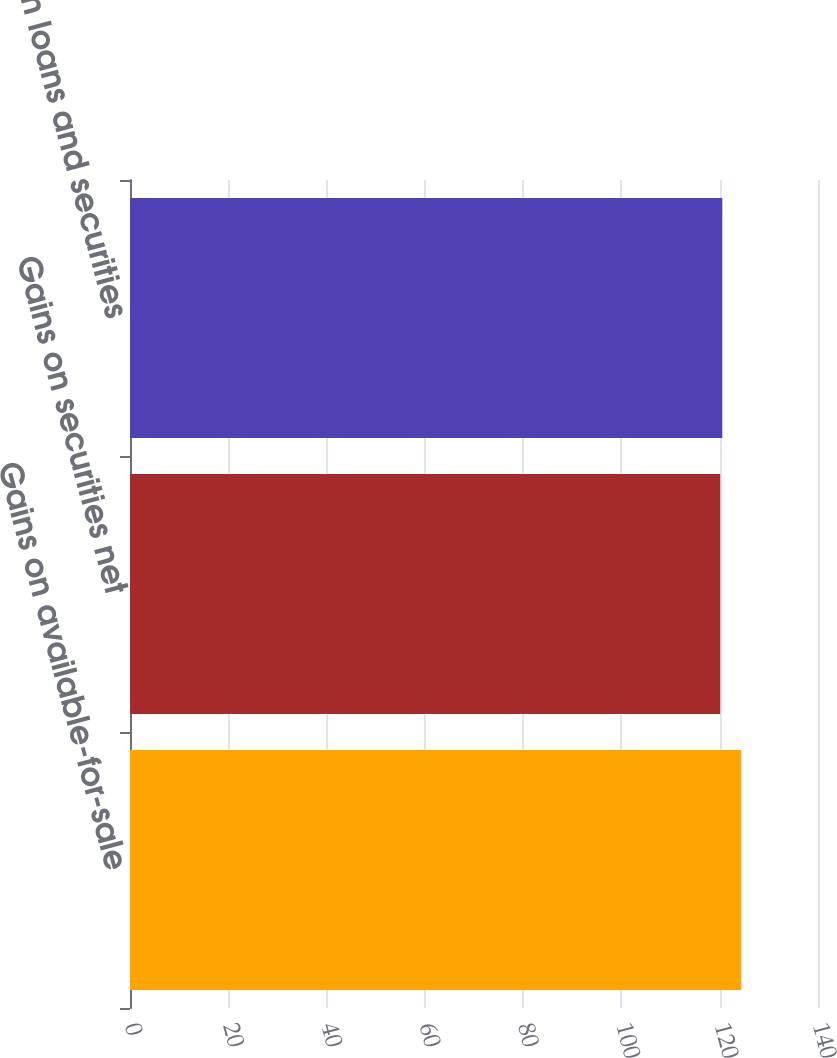Convert chart. <chart><loc_0><loc_0><loc_500><loc_500><bar_chart><fcel>Gains on available-for-sale<fcel>Gains on securities net<fcel>Gains on loans and securities<nl><fcel>124.4<fcel>120.1<fcel>120.53<nl></chart> 